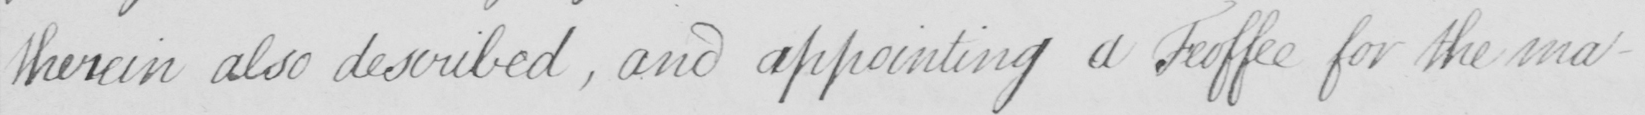What does this handwritten line say? therein also described  , and appointing a Feoffee for the ma- 